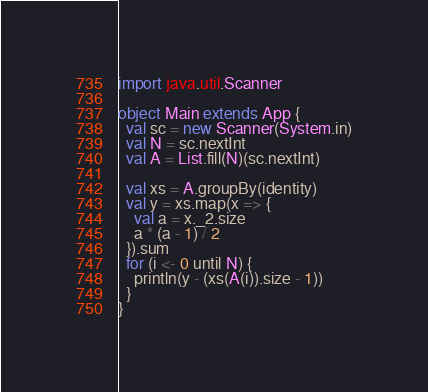<code> <loc_0><loc_0><loc_500><loc_500><_Scala_>import java.util.Scanner

object Main extends App {
  val sc = new Scanner(System.in)
  val N = sc.nextInt
  val A = List.fill(N)(sc.nextInt)

  val xs = A.groupBy(identity)
  val y = xs.map(x => {
    val a = x._2.size
    a * (a - 1) / 2
  }).sum
  for (i <- 0 until N) {
    println(y - (xs(A(i)).size - 1))
  }
}
</code> 